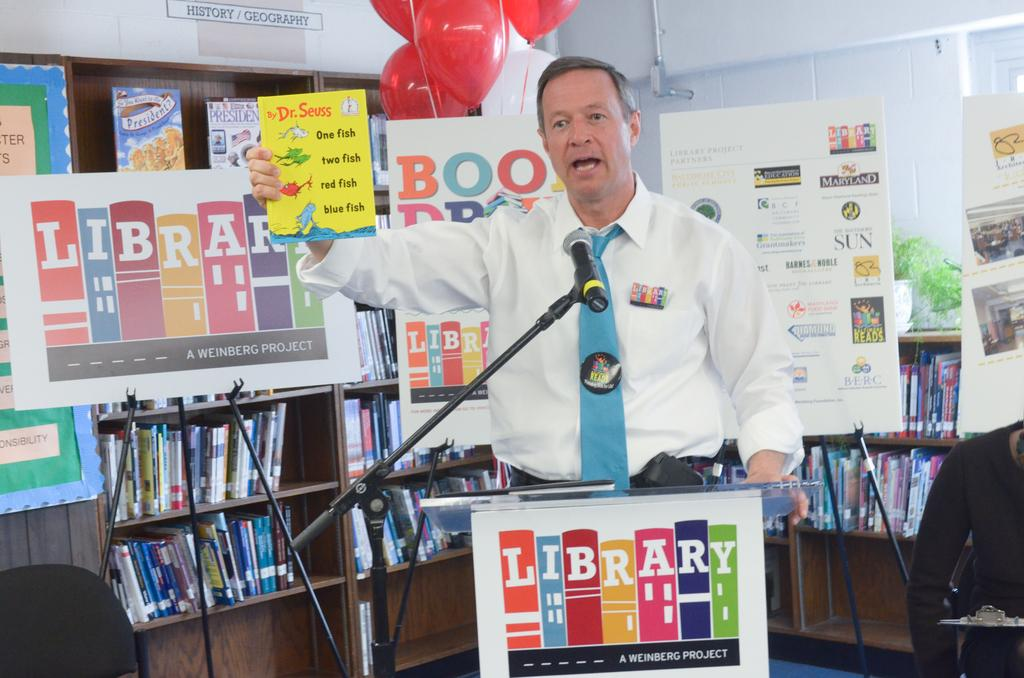<image>
Describe the image concisely. A man standing behind a sign that says Library on it. 